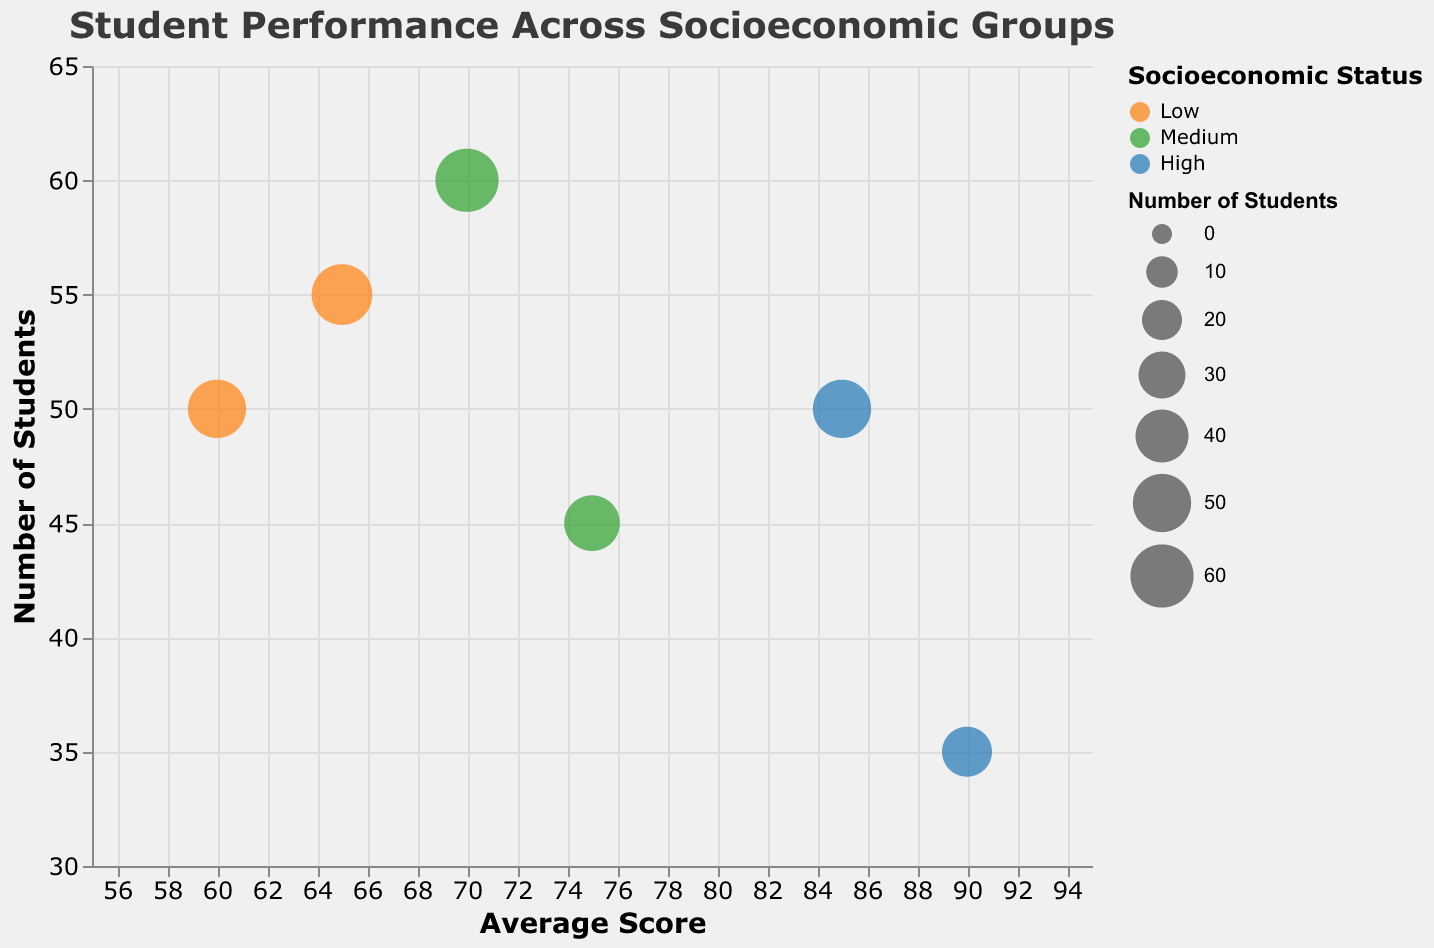Which socioeconomic group has the highest average score? The figure shows bubbles representing different socioeconomic groups, and the position on the x-axis indicates the average score. The bubble for "Sunnydale Prep" in the "High" socioeconomic group is furthest to the right, indicating a highest average score of 90.
Answer: High Which school has the most students in the "Medium" socioeconomic status category? Identify the bubbles colored to represent the "Medium" socioeconomic status and then see which one is positioned highest on the y-axis. "Brookfield Academy" has 60 students, the highest among the "Medium" category.
Answer: Brookfield Academy What is the difference in average scores between the schools with the highest and lowest student numbers? Locate the bubbles for the schools with the highest and lowest y-axis values (Brookfield Academy and Sunnydale Prep, respectively). Brookfield Academy's average score is 70, and Sunnydale Prep's average score is 90. The difference is 90 - 70 = 20.
Answer: 20 Which school in the "Low" socioeconomic group has a higher average score? Identify the bubbles colored to represent the "Low" socioeconomic status. Compare their positions on the x-axis. "Lakeside High" has an average score of 65, which is higher than "Green Valley" with an average score of 60.
Answer: Lakeside High What is the average number of students in the "High" socioeconomic group? Find the bubbles for "Hillside High" and "Sunnydale Prep" (both in the "High" group). Their student numbers are 50 and 35, respectively. (50 + 35) / 2 = 42.5.
Answer: 42.5 How does the average score of "Riverside School" compare to that of "Green Valley"? Locate the bubbles for "Riverside School" and "Green Valley" and compare their positions on the x-axis. "Riverside School" has an average score of 75, while "Green Valley" has an average score of 60. 75 is greater than 60.
Answer: Riverside School's score is higher What is the range of average scores across all schools? Find the highest and lowest positions on the x-axis. "Sunnydale Prep" has the highest average score of 90 and "Green Valley" has the lowest at 60. The range is 90 - 60 = 30.
Answer: 30 